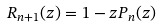Convert formula to latex. <formula><loc_0><loc_0><loc_500><loc_500>R _ { n + 1 } ( z ) = 1 - z P _ { n } ( z )</formula> 